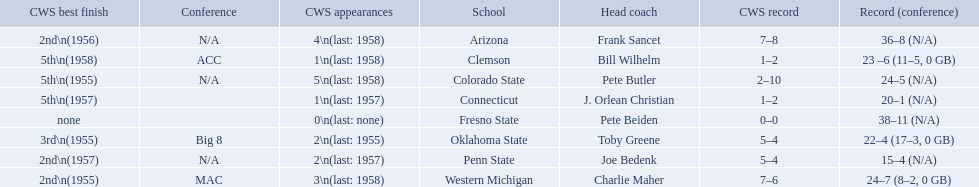What were scores for each school in the 1959 ncaa tournament? 36–8 (N/A), 23 –6 (11–5, 0 GB), 24–5 (N/A), 20–1 (N/A), 38–11 (N/A), 22–4 (17–3, 0 GB), 15–4 (N/A), 24–7 (8–2, 0 GB). What score did not have at least 16 wins? 15–4 (N/A). What team earned this score? Penn State. 